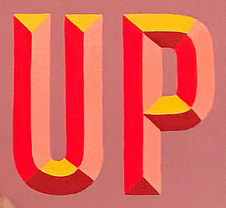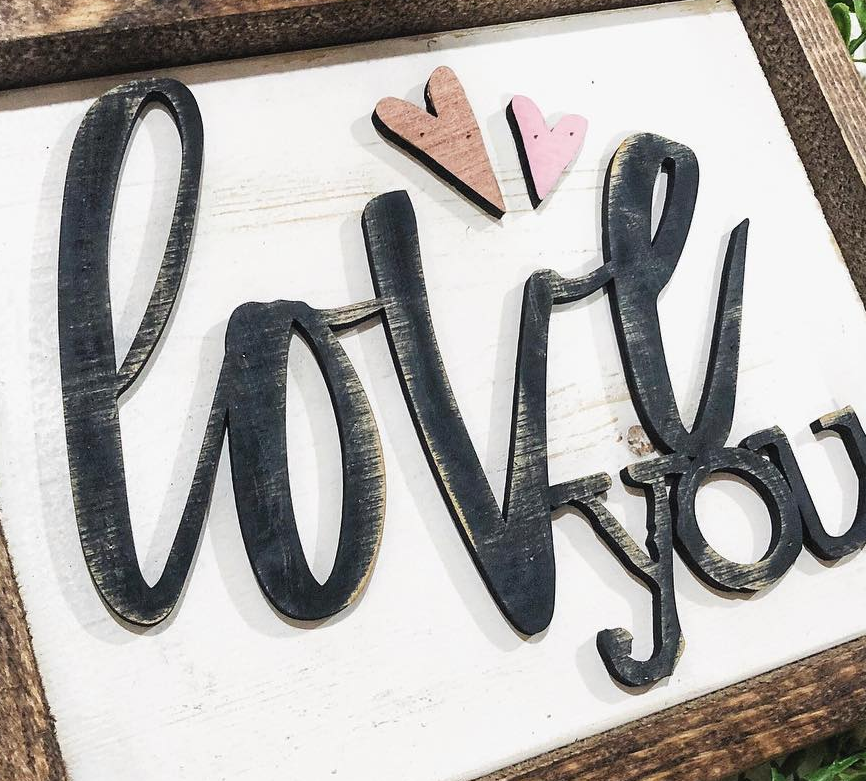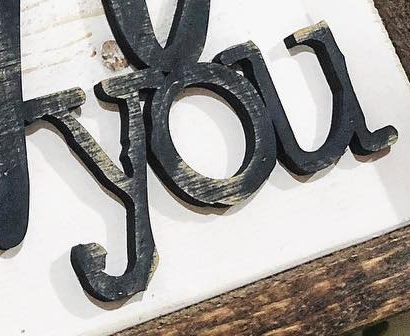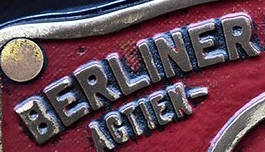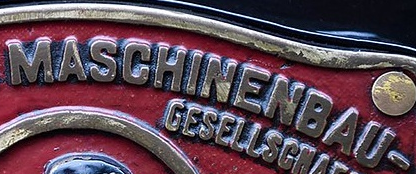What words are shown in these images in order, separated by a semicolon? UP; love; you; BERLINER; MASCHINENBAU 